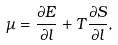Convert formula to latex. <formula><loc_0><loc_0><loc_500><loc_500>\mu = \frac { \partial E } { \partial l } + T \frac { \partial S } { \partial l } ,</formula> 